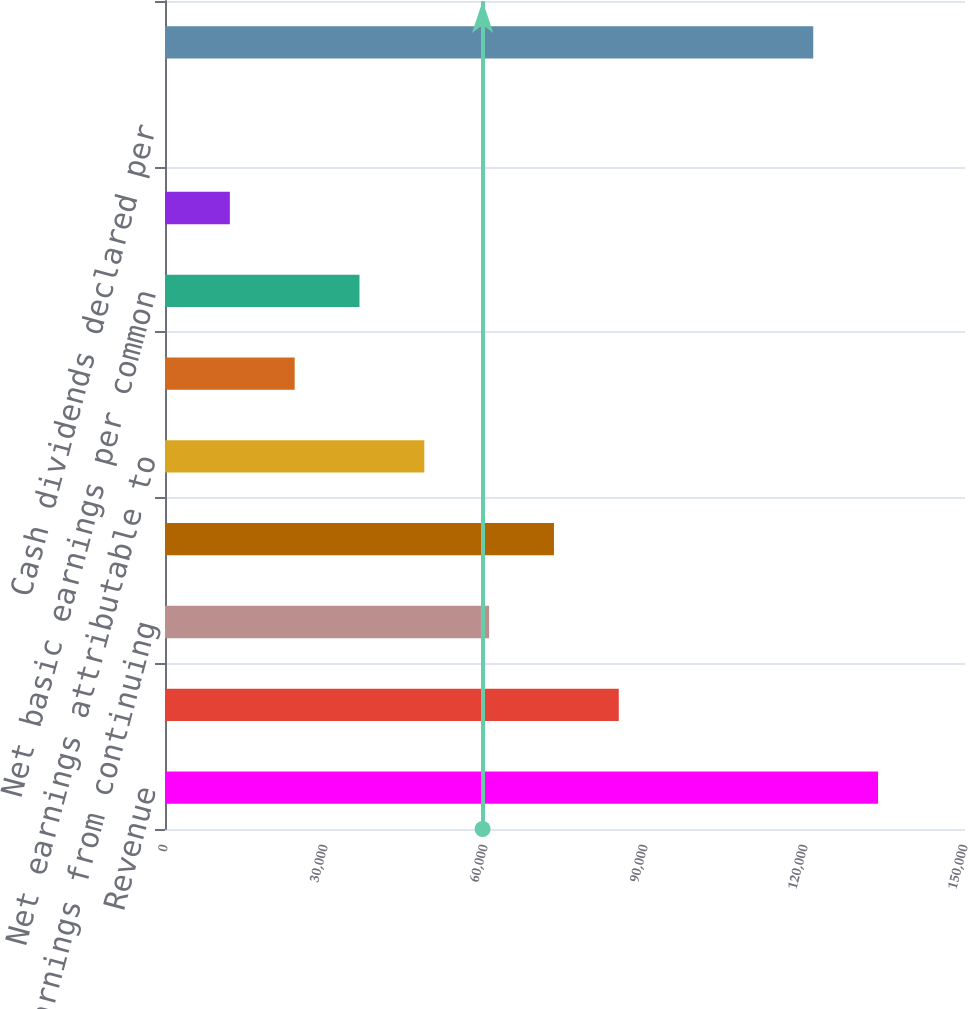<chart> <loc_0><loc_0><loc_500><loc_500><bar_chart><fcel>Revenue<fcel>Operating earnings<fcel>Earnings from continuing<fcel>Net earnings<fcel>Net earnings attributable to<fcel>Continuing operations<fcel>Net basic earnings per common<fcel>Net diluted earnings per<fcel>Cash dividends declared per<fcel>Total assets<nl><fcel>133700<fcel>85082.7<fcel>60773.8<fcel>72928.2<fcel>48619.4<fcel>24310.5<fcel>36464.9<fcel>12156<fcel>1.61<fcel>121546<nl></chart> 